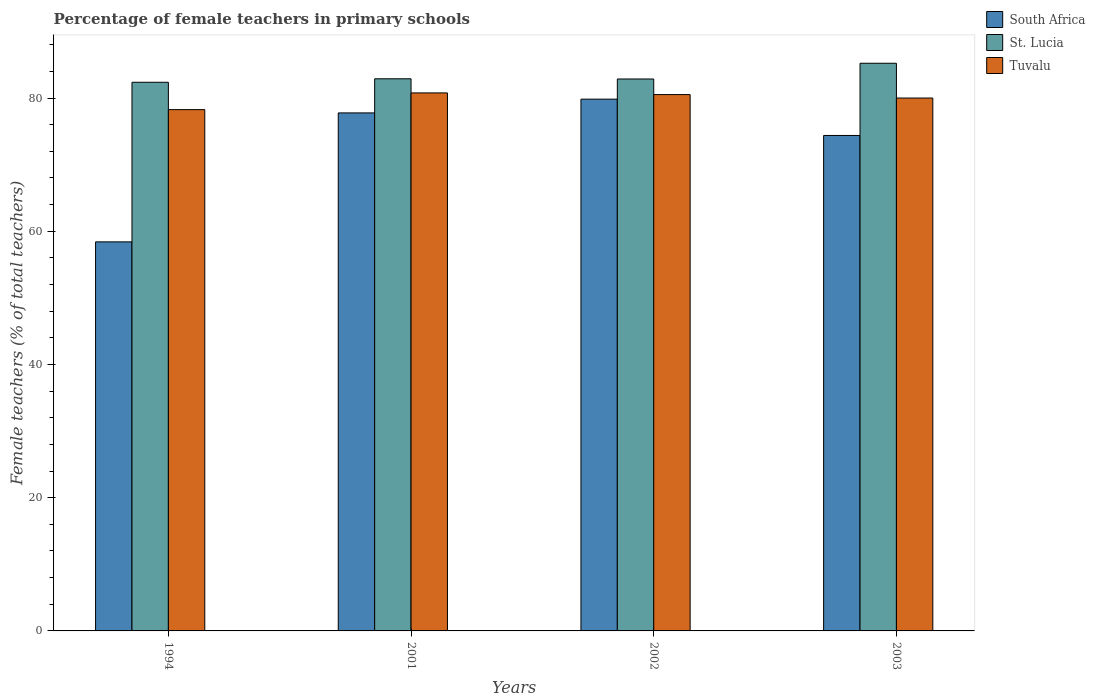How many different coloured bars are there?
Provide a succinct answer. 3. Are the number of bars per tick equal to the number of legend labels?
Provide a short and direct response. Yes. Are the number of bars on each tick of the X-axis equal?
Make the answer very short. Yes. What is the label of the 1st group of bars from the left?
Your response must be concise. 1994. In how many cases, is the number of bars for a given year not equal to the number of legend labels?
Make the answer very short. 0. Across all years, what is the maximum percentage of female teachers in St. Lucia?
Offer a terse response. 85.22. Across all years, what is the minimum percentage of female teachers in Tuvalu?
Ensure brevity in your answer.  78.26. In which year was the percentage of female teachers in Tuvalu maximum?
Your answer should be very brief. 2001. What is the total percentage of female teachers in St. Lucia in the graph?
Your answer should be compact. 333.34. What is the difference between the percentage of female teachers in St. Lucia in 2001 and that in 2002?
Keep it short and to the point. 0.03. What is the difference between the percentage of female teachers in Tuvalu in 2001 and the percentage of female teachers in St. Lucia in 1994?
Provide a short and direct response. -1.6. What is the average percentage of female teachers in South Africa per year?
Your answer should be very brief. 72.6. In the year 1994, what is the difference between the percentage of female teachers in South Africa and percentage of female teachers in Tuvalu?
Give a very brief answer. -19.85. In how many years, is the percentage of female teachers in Tuvalu greater than 24 %?
Ensure brevity in your answer.  4. What is the ratio of the percentage of female teachers in Tuvalu in 1994 to that in 2002?
Your answer should be compact. 0.97. Is the percentage of female teachers in St. Lucia in 1994 less than that in 2001?
Make the answer very short. Yes. Is the difference between the percentage of female teachers in South Africa in 2001 and 2003 greater than the difference between the percentage of female teachers in Tuvalu in 2001 and 2003?
Your answer should be very brief. Yes. What is the difference between the highest and the second highest percentage of female teachers in South Africa?
Give a very brief answer. 2.07. What is the difference between the highest and the lowest percentage of female teachers in St. Lucia?
Provide a short and direct response. 2.85. What does the 2nd bar from the left in 1994 represents?
Keep it short and to the point. St. Lucia. What does the 3rd bar from the right in 2001 represents?
Your answer should be very brief. South Africa. Is it the case that in every year, the sum of the percentage of female teachers in Tuvalu and percentage of female teachers in St. Lucia is greater than the percentage of female teachers in South Africa?
Offer a very short reply. Yes. Are all the bars in the graph horizontal?
Your answer should be compact. No. How many years are there in the graph?
Offer a very short reply. 4. Where does the legend appear in the graph?
Provide a short and direct response. Top right. How many legend labels are there?
Your answer should be compact. 3. What is the title of the graph?
Your response must be concise. Percentage of female teachers in primary schools. What is the label or title of the Y-axis?
Ensure brevity in your answer.  Female teachers (% of total teachers). What is the Female teachers (% of total teachers) of South Africa in 1994?
Provide a short and direct response. 58.41. What is the Female teachers (% of total teachers) of St. Lucia in 1994?
Your answer should be compact. 82.37. What is the Female teachers (% of total teachers) in Tuvalu in 1994?
Ensure brevity in your answer.  78.26. What is the Female teachers (% of total teachers) in South Africa in 2001?
Provide a succinct answer. 77.77. What is the Female teachers (% of total teachers) in St. Lucia in 2001?
Make the answer very short. 82.89. What is the Female teachers (% of total teachers) in Tuvalu in 2001?
Make the answer very short. 80.77. What is the Female teachers (% of total teachers) of South Africa in 2002?
Provide a succinct answer. 79.83. What is the Female teachers (% of total teachers) in St. Lucia in 2002?
Provide a succinct answer. 82.86. What is the Female teachers (% of total teachers) of Tuvalu in 2002?
Ensure brevity in your answer.  80.52. What is the Female teachers (% of total teachers) of South Africa in 2003?
Provide a succinct answer. 74.38. What is the Female teachers (% of total teachers) in St. Lucia in 2003?
Provide a succinct answer. 85.22. Across all years, what is the maximum Female teachers (% of total teachers) of South Africa?
Provide a short and direct response. 79.83. Across all years, what is the maximum Female teachers (% of total teachers) of St. Lucia?
Your answer should be compact. 85.22. Across all years, what is the maximum Female teachers (% of total teachers) of Tuvalu?
Offer a terse response. 80.77. Across all years, what is the minimum Female teachers (% of total teachers) of South Africa?
Make the answer very short. 58.41. Across all years, what is the minimum Female teachers (% of total teachers) in St. Lucia?
Your response must be concise. 82.37. Across all years, what is the minimum Female teachers (% of total teachers) in Tuvalu?
Your answer should be very brief. 78.26. What is the total Female teachers (% of total teachers) in South Africa in the graph?
Ensure brevity in your answer.  290.39. What is the total Female teachers (% of total teachers) of St. Lucia in the graph?
Ensure brevity in your answer.  333.34. What is the total Female teachers (% of total teachers) in Tuvalu in the graph?
Your answer should be compact. 319.55. What is the difference between the Female teachers (% of total teachers) in South Africa in 1994 and that in 2001?
Ensure brevity in your answer.  -19.36. What is the difference between the Female teachers (% of total teachers) of St. Lucia in 1994 and that in 2001?
Offer a very short reply. -0.52. What is the difference between the Female teachers (% of total teachers) of Tuvalu in 1994 and that in 2001?
Your response must be concise. -2.51. What is the difference between the Female teachers (% of total teachers) in South Africa in 1994 and that in 2002?
Offer a very short reply. -21.43. What is the difference between the Female teachers (% of total teachers) of St. Lucia in 1994 and that in 2002?
Ensure brevity in your answer.  -0.49. What is the difference between the Female teachers (% of total teachers) of Tuvalu in 1994 and that in 2002?
Your response must be concise. -2.26. What is the difference between the Female teachers (% of total teachers) in South Africa in 1994 and that in 2003?
Make the answer very short. -15.97. What is the difference between the Female teachers (% of total teachers) of St. Lucia in 1994 and that in 2003?
Make the answer very short. -2.85. What is the difference between the Female teachers (% of total teachers) in Tuvalu in 1994 and that in 2003?
Keep it short and to the point. -1.74. What is the difference between the Female teachers (% of total teachers) in South Africa in 2001 and that in 2002?
Keep it short and to the point. -2.07. What is the difference between the Female teachers (% of total teachers) in St. Lucia in 2001 and that in 2002?
Offer a very short reply. 0.03. What is the difference between the Female teachers (% of total teachers) of Tuvalu in 2001 and that in 2002?
Provide a succinct answer. 0.25. What is the difference between the Female teachers (% of total teachers) of South Africa in 2001 and that in 2003?
Keep it short and to the point. 3.39. What is the difference between the Female teachers (% of total teachers) in St. Lucia in 2001 and that in 2003?
Provide a succinct answer. -2.33. What is the difference between the Female teachers (% of total teachers) in Tuvalu in 2001 and that in 2003?
Provide a short and direct response. 0.77. What is the difference between the Female teachers (% of total teachers) of South Africa in 2002 and that in 2003?
Provide a succinct answer. 5.45. What is the difference between the Female teachers (% of total teachers) of St. Lucia in 2002 and that in 2003?
Make the answer very short. -2.36. What is the difference between the Female teachers (% of total teachers) of Tuvalu in 2002 and that in 2003?
Provide a short and direct response. 0.52. What is the difference between the Female teachers (% of total teachers) of South Africa in 1994 and the Female teachers (% of total teachers) of St. Lucia in 2001?
Ensure brevity in your answer.  -24.48. What is the difference between the Female teachers (% of total teachers) of South Africa in 1994 and the Female teachers (% of total teachers) of Tuvalu in 2001?
Provide a succinct answer. -22.36. What is the difference between the Female teachers (% of total teachers) in St. Lucia in 1994 and the Female teachers (% of total teachers) in Tuvalu in 2001?
Provide a short and direct response. 1.6. What is the difference between the Female teachers (% of total teachers) of South Africa in 1994 and the Female teachers (% of total teachers) of St. Lucia in 2002?
Provide a short and direct response. -24.45. What is the difference between the Female teachers (% of total teachers) in South Africa in 1994 and the Female teachers (% of total teachers) in Tuvalu in 2002?
Your answer should be compact. -22.11. What is the difference between the Female teachers (% of total teachers) of St. Lucia in 1994 and the Female teachers (% of total teachers) of Tuvalu in 2002?
Keep it short and to the point. 1.85. What is the difference between the Female teachers (% of total teachers) in South Africa in 1994 and the Female teachers (% of total teachers) in St. Lucia in 2003?
Provide a short and direct response. -26.81. What is the difference between the Female teachers (% of total teachers) of South Africa in 1994 and the Female teachers (% of total teachers) of Tuvalu in 2003?
Your answer should be compact. -21.59. What is the difference between the Female teachers (% of total teachers) of St. Lucia in 1994 and the Female teachers (% of total teachers) of Tuvalu in 2003?
Your answer should be compact. 2.37. What is the difference between the Female teachers (% of total teachers) of South Africa in 2001 and the Female teachers (% of total teachers) of St. Lucia in 2002?
Your answer should be very brief. -5.09. What is the difference between the Female teachers (% of total teachers) in South Africa in 2001 and the Female teachers (% of total teachers) in Tuvalu in 2002?
Provide a short and direct response. -2.75. What is the difference between the Female teachers (% of total teachers) in St. Lucia in 2001 and the Female teachers (% of total teachers) in Tuvalu in 2002?
Offer a terse response. 2.37. What is the difference between the Female teachers (% of total teachers) of South Africa in 2001 and the Female teachers (% of total teachers) of St. Lucia in 2003?
Make the answer very short. -7.45. What is the difference between the Female teachers (% of total teachers) of South Africa in 2001 and the Female teachers (% of total teachers) of Tuvalu in 2003?
Offer a very short reply. -2.23. What is the difference between the Female teachers (% of total teachers) in St. Lucia in 2001 and the Female teachers (% of total teachers) in Tuvalu in 2003?
Give a very brief answer. 2.89. What is the difference between the Female teachers (% of total teachers) in South Africa in 2002 and the Female teachers (% of total teachers) in St. Lucia in 2003?
Provide a succinct answer. -5.39. What is the difference between the Female teachers (% of total teachers) of South Africa in 2002 and the Female teachers (% of total teachers) of Tuvalu in 2003?
Keep it short and to the point. -0.17. What is the difference between the Female teachers (% of total teachers) in St. Lucia in 2002 and the Female teachers (% of total teachers) in Tuvalu in 2003?
Offer a terse response. 2.86. What is the average Female teachers (% of total teachers) of South Africa per year?
Ensure brevity in your answer.  72.6. What is the average Female teachers (% of total teachers) in St. Lucia per year?
Make the answer very short. 83.33. What is the average Female teachers (% of total teachers) in Tuvalu per year?
Provide a succinct answer. 79.89. In the year 1994, what is the difference between the Female teachers (% of total teachers) in South Africa and Female teachers (% of total teachers) in St. Lucia?
Provide a short and direct response. -23.96. In the year 1994, what is the difference between the Female teachers (% of total teachers) of South Africa and Female teachers (% of total teachers) of Tuvalu?
Provide a short and direct response. -19.85. In the year 1994, what is the difference between the Female teachers (% of total teachers) of St. Lucia and Female teachers (% of total teachers) of Tuvalu?
Offer a very short reply. 4.11. In the year 2001, what is the difference between the Female teachers (% of total teachers) in South Africa and Female teachers (% of total teachers) in St. Lucia?
Keep it short and to the point. -5.12. In the year 2001, what is the difference between the Female teachers (% of total teachers) in South Africa and Female teachers (% of total teachers) in Tuvalu?
Offer a terse response. -3. In the year 2001, what is the difference between the Female teachers (% of total teachers) in St. Lucia and Female teachers (% of total teachers) in Tuvalu?
Your answer should be compact. 2.12. In the year 2002, what is the difference between the Female teachers (% of total teachers) of South Africa and Female teachers (% of total teachers) of St. Lucia?
Give a very brief answer. -3.03. In the year 2002, what is the difference between the Female teachers (% of total teachers) in South Africa and Female teachers (% of total teachers) in Tuvalu?
Ensure brevity in your answer.  -0.68. In the year 2002, what is the difference between the Female teachers (% of total teachers) in St. Lucia and Female teachers (% of total teachers) in Tuvalu?
Make the answer very short. 2.34. In the year 2003, what is the difference between the Female teachers (% of total teachers) in South Africa and Female teachers (% of total teachers) in St. Lucia?
Keep it short and to the point. -10.84. In the year 2003, what is the difference between the Female teachers (% of total teachers) of South Africa and Female teachers (% of total teachers) of Tuvalu?
Keep it short and to the point. -5.62. In the year 2003, what is the difference between the Female teachers (% of total teachers) in St. Lucia and Female teachers (% of total teachers) in Tuvalu?
Offer a very short reply. 5.22. What is the ratio of the Female teachers (% of total teachers) of South Africa in 1994 to that in 2001?
Keep it short and to the point. 0.75. What is the ratio of the Female teachers (% of total teachers) in St. Lucia in 1994 to that in 2001?
Provide a succinct answer. 0.99. What is the ratio of the Female teachers (% of total teachers) of Tuvalu in 1994 to that in 2001?
Keep it short and to the point. 0.97. What is the ratio of the Female teachers (% of total teachers) of South Africa in 1994 to that in 2002?
Provide a short and direct response. 0.73. What is the ratio of the Female teachers (% of total teachers) in St. Lucia in 1994 to that in 2002?
Keep it short and to the point. 0.99. What is the ratio of the Female teachers (% of total teachers) of Tuvalu in 1994 to that in 2002?
Provide a short and direct response. 0.97. What is the ratio of the Female teachers (% of total teachers) in South Africa in 1994 to that in 2003?
Give a very brief answer. 0.79. What is the ratio of the Female teachers (% of total teachers) of St. Lucia in 1994 to that in 2003?
Provide a succinct answer. 0.97. What is the ratio of the Female teachers (% of total teachers) of Tuvalu in 1994 to that in 2003?
Your answer should be very brief. 0.98. What is the ratio of the Female teachers (% of total teachers) in South Africa in 2001 to that in 2002?
Make the answer very short. 0.97. What is the ratio of the Female teachers (% of total teachers) in St. Lucia in 2001 to that in 2002?
Make the answer very short. 1. What is the ratio of the Female teachers (% of total teachers) in South Africa in 2001 to that in 2003?
Provide a short and direct response. 1.05. What is the ratio of the Female teachers (% of total teachers) in St. Lucia in 2001 to that in 2003?
Provide a succinct answer. 0.97. What is the ratio of the Female teachers (% of total teachers) of Tuvalu in 2001 to that in 2003?
Make the answer very short. 1.01. What is the ratio of the Female teachers (% of total teachers) of South Africa in 2002 to that in 2003?
Provide a short and direct response. 1.07. What is the ratio of the Female teachers (% of total teachers) of St. Lucia in 2002 to that in 2003?
Offer a terse response. 0.97. What is the ratio of the Female teachers (% of total teachers) in Tuvalu in 2002 to that in 2003?
Offer a very short reply. 1.01. What is the difference between the highest and the second highest Female teachers (% of total teachers) in South Africa?
Provide a short and direct response. 2.07. What is the difference between the highest and the second highest Female teachers (% of total teachers) in St. Lucia?
Offer a terse response. 2.33. What is the difference between the highest and the second highest Female teachers (% of total teachers) of Tuvalu?
Your response must be concise. 0.25. What is the difference between the highest and the lowest Female teachers (% of total teachers) in South Africa?
Provide a short and direct response. 21.43. What is the difference between the highest and the lowest Female teachers (% of total teachers) of St. Lucia?
Provide a succinct answer. 2.85. What is the difference between the highest and the lowest Female teachers (% of total teachers) in Tuvalu?
Provide a short and direct response. 2.51. 